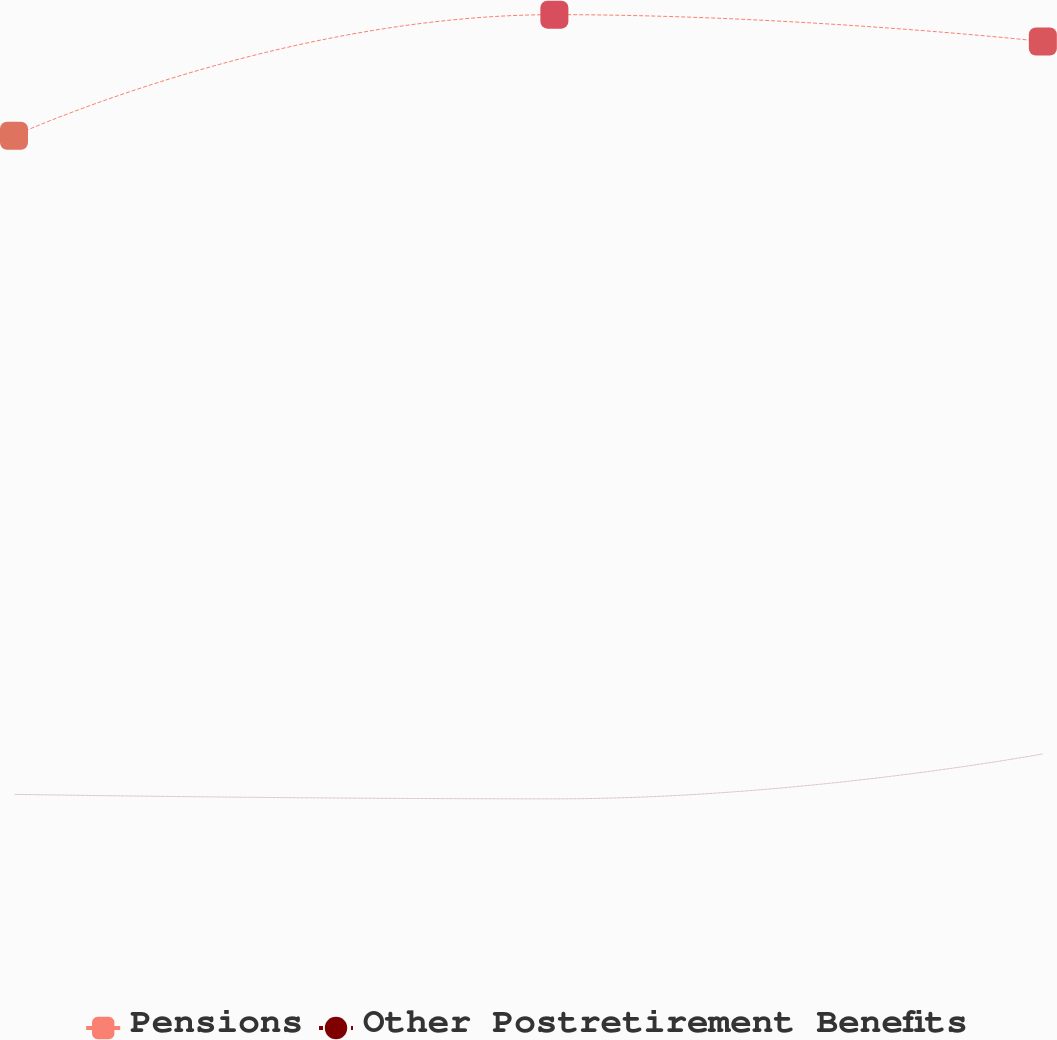<chart> <loc_0><loc_0><loc_500><loc_500><line_chart><ecel><fcel>Pensions<fcel>Other Postretirement Benefits<nl><fcel>1689.96<fcel>2917.64<fcel>516.42<nl><fcel>1961.19<fcel>3359.04<fcel>500.02<nl><fcel>2206.37<fcel>3261.28<fcel>664.02<nl><fcel>2269.4<fcel>3310.16<fcel>597.41<nl><fcel>2332.43<fcel>2817.76<fcel>532.82<nl></chart> 